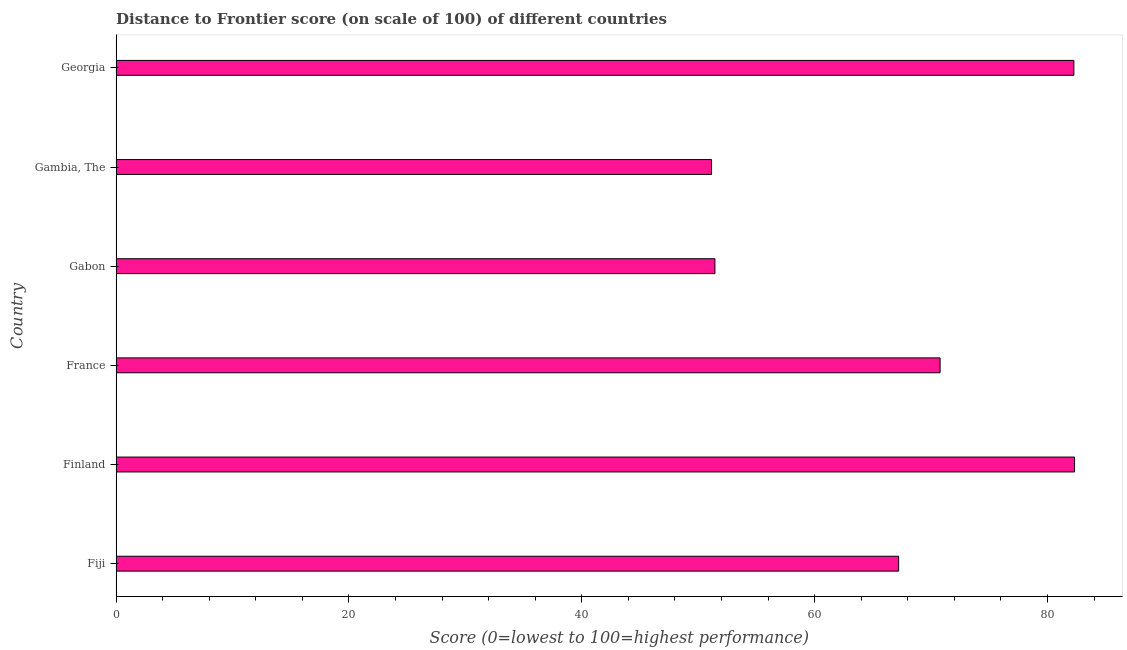What is the title of the graph?
Offer a very short reply. Distance to Frontier score (on scale of 100) of different countries. What is the label or title of the X-axis?
Keep it short and to the point. Score (0=lowest to 100=highest performance). What is the distance to frontier score in Georgia?
Provide a short and direct response. 82.26. Across all countries, what is the maximum distance to frontier score?
Keep it short and to the point. 82.32. Across all countries, what is the minimum distance to frontier score?
Offer a very short reply. 51.14. In which country was the distance to frontier score maximum?
Your response must be concise. Finland. In which country was the distance to frontier score minimum?
Offer a very short reply. Gambia, The. What is the sum of the distance to frontier score?
Provide a succinct answer. 405.13. What is the difference between the distance to frontier score in Gabon and Gambia, The?
Offer a very short reply. 0.29. What is the average distance to frontier score per country?
Make the answer very short. 67.52. What is the median distance to frontier score?
Your answer should be very brief. 68.99. What is the ratio of the distance to frontier score in France to that in Georgia?
Your response must be concise. 0.86. Is the sum of the distance to frontier score in France and Gabon greater than the maximum distance to frontier score across all countries?
Offer a terse response. Yes. What is the difference between the highest and the lowest distance to frontier score?
Your response must be concise. 31.18. In how many countries, is the distance to frontier score greater than the average distance to frontier score taken over all countries?
Make the answer very short. 3. How many bars are there?
Your response must be concise. 6. How many countries are there in the graph?
Keep it short and to the point. 6. What is the difference between two consecutive major ticks on the X-axis?
Offer a very short reply. 20. What is the Score (0=lowest to 100=highest performance) of Fiji?
Your answer should be compact. 67.21. What is the Score (0=lowest to 100=highest performance) in Finland?
Offer a terse response. 82.32. What is the Score (0=lowest to 100=highest performance) of France?
Offer a very short reply. 70.77. What is the Score (0=lowest to 100=highest performance) in Gabon?
Ensure brevity in your answer.  51.43. What is the Score (0=lowest to 100=highest performance) of Gambia, The?
Your answer should be very brief. 51.14. What is the Score (0=lowest to 100=highest performance) in Georgia?
Make the answer very short. 82.26. What is the difference between the Score (0=lowest to 100=highest performance) in Fiji and Finland?
Provide a short and direct response. -15.11. What is the difference between the Score (0=lowest to 100=highest performance) in Fiji and France?
Provide a short and direct response. -3.56. What is the difference between the Score (0=lowest to 100=highest performance) in Fiji and Gabon?
Your answer should be compact. 15.78. What is the difference between the Score (0=lowest to 100=highest performance) in Fiji and Gambia, The?
Provide a succinct answer. 16.07. What is the difference between the Score (0=lowest to 100=highest performance) in Fiji and Georgia?
Make the answer very short. -15.05. What is the difference between the Score (0=lowest to 100=highest performance) in Finland and France?
Provide a short and direct response. 11.55. What is the difference between the Score (0=lowest to 100=highest performance) in Finland and Gabon?
Your answer should be compact. 30.89. What is the difference between the Score (0=lowest to 100=highest performance) in Finland and Gambia, The?
Your answer should be compact. 31.18. What is the difference between the Score (0=lowest to 100=highest performance) in Finland and Georgia?
Keep it short and to the point. 0.06. What is the difference between the Score (0=lowest to 100=highest performance) in France and Gabon?
Offer a very short reply. 19.34. What is the difference between the Score (0=lowest to 100=highest performance) in France and Gambia, The?
Make the answer very short. 19.63. What is the difference between the Score (0=lowest to 100=highest performance) in France and Georgia?
Your answer should be compact. -11.49. What is the difference between the Score (0=lowest to 100=highest performance) in Gabon and Gambia, The?
Give a very brief answer. 0.29. What is the difference between the Score (0=lowest to 100=highest performance) in Gabon and Georgia?
Your answer should be compact. -30.83. What is the difference between the Score (0=lowest to 100=highest performance) in Gambia, The and Georgia?
Provide a short and direct response. -31.12. What is the ratio of the Score (0=lowest to 100=highest performance) in Fiji to that in Finland?
Your response must be concise. 0.82. What is the ratio of the Score (0=lowest to 100=highest performance) in Fiji to that in Gabon?
Offer a very short reply. 1.31. What is the ratio of the Score (0=lowest to 100=highest performance) in Fiji to that in Gambia, The?
Give a very brief answer. 1.31. What is the ratio of the Score (0=lowest to 100=highest performance) in Fiji to that in Georgia?
Ensure brevity in your answer.  0.82. What is the ratio of the Score (0=lowest to 100=highest performance) in Finland to that in France?
Your response must be concise. 1.16. What is the ratio of the Score (0=lowest to 100=highest performance) in Finland to that in Gabon?
Provide a succinct answer. 1.6. What is the ratio of the Score (0=lowest to 100=highest performance) in Finland to that in Gambia, The?
Provide a succinct answer. 1.61. What is the ratio of the Score (0=lowest to 100=highest performance) in France to that in Gabon?
Provide a short and direct response. 1.38. What is the ratio of the Score (0=lowest to 100=highest performance) in France to that in Gambia, The?
Provide a succinct answer. 1.38. What is the ratio of the Score (0=lowest to 100=highest performance) in France to that in Georgia?
Provide a succinct answer. 0.86. What is the ratio of the Score (0=lowest to 100=highest performance) in Gabon to that in Gambia, The?
Offer a terse response. 1.01. What is the ratio of the Score (0=lowest to 100=highest performance) in Gambia, The to that in Georgia?
Offer a very short reply. 0.62. 